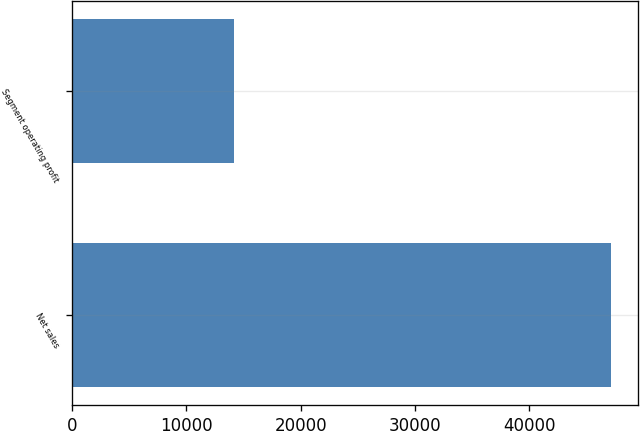Convert chart. <chart><loc_0><loc_0><loc_500><loc_500><bar_chart><fcel>Net sales<fcel>Segment operating profit<nl><fcel>47132<fcel>14129<nl></chart> 